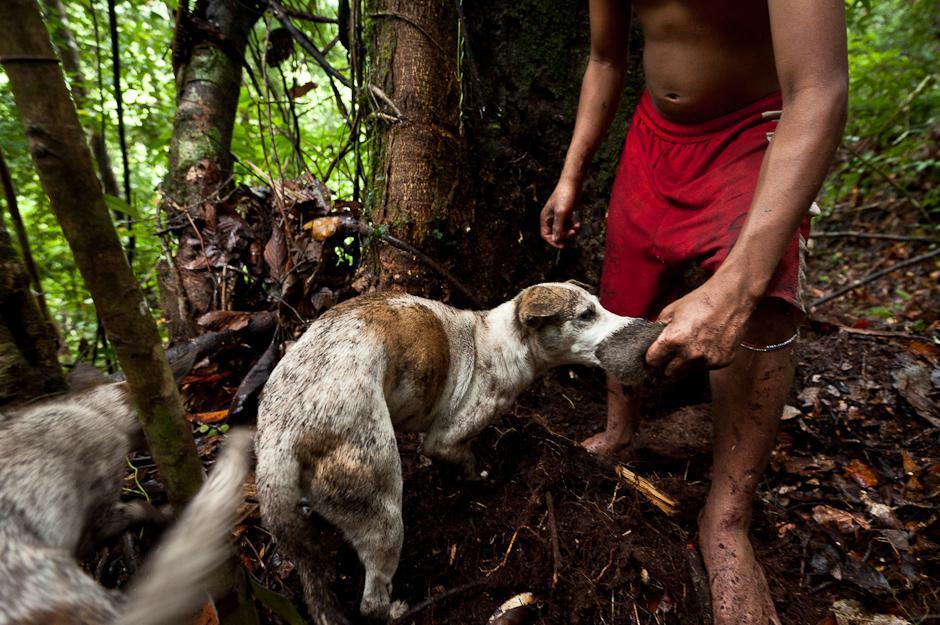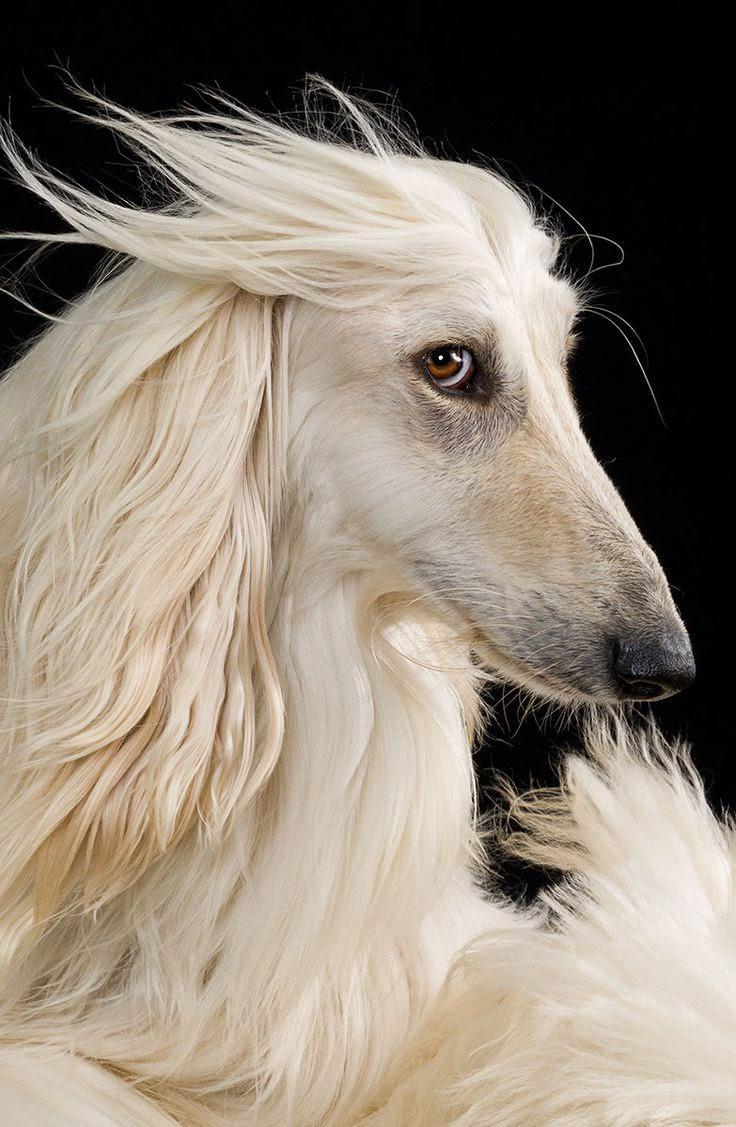The first image is the image on the left, the second image is the image on the right. Evaluate the accuracy of this statement regarding the images: "Both images in the pair are paintings of dogs and not real dogs.". Is it true? Answer yes or no. No. The first image is the image on the left, the second image is the image on the right. Considering the images on both sides, is "Each image depicts multiple hounds, and the right image includes at least one hound in a bounding pose." valid? Answer yes or no. No. 